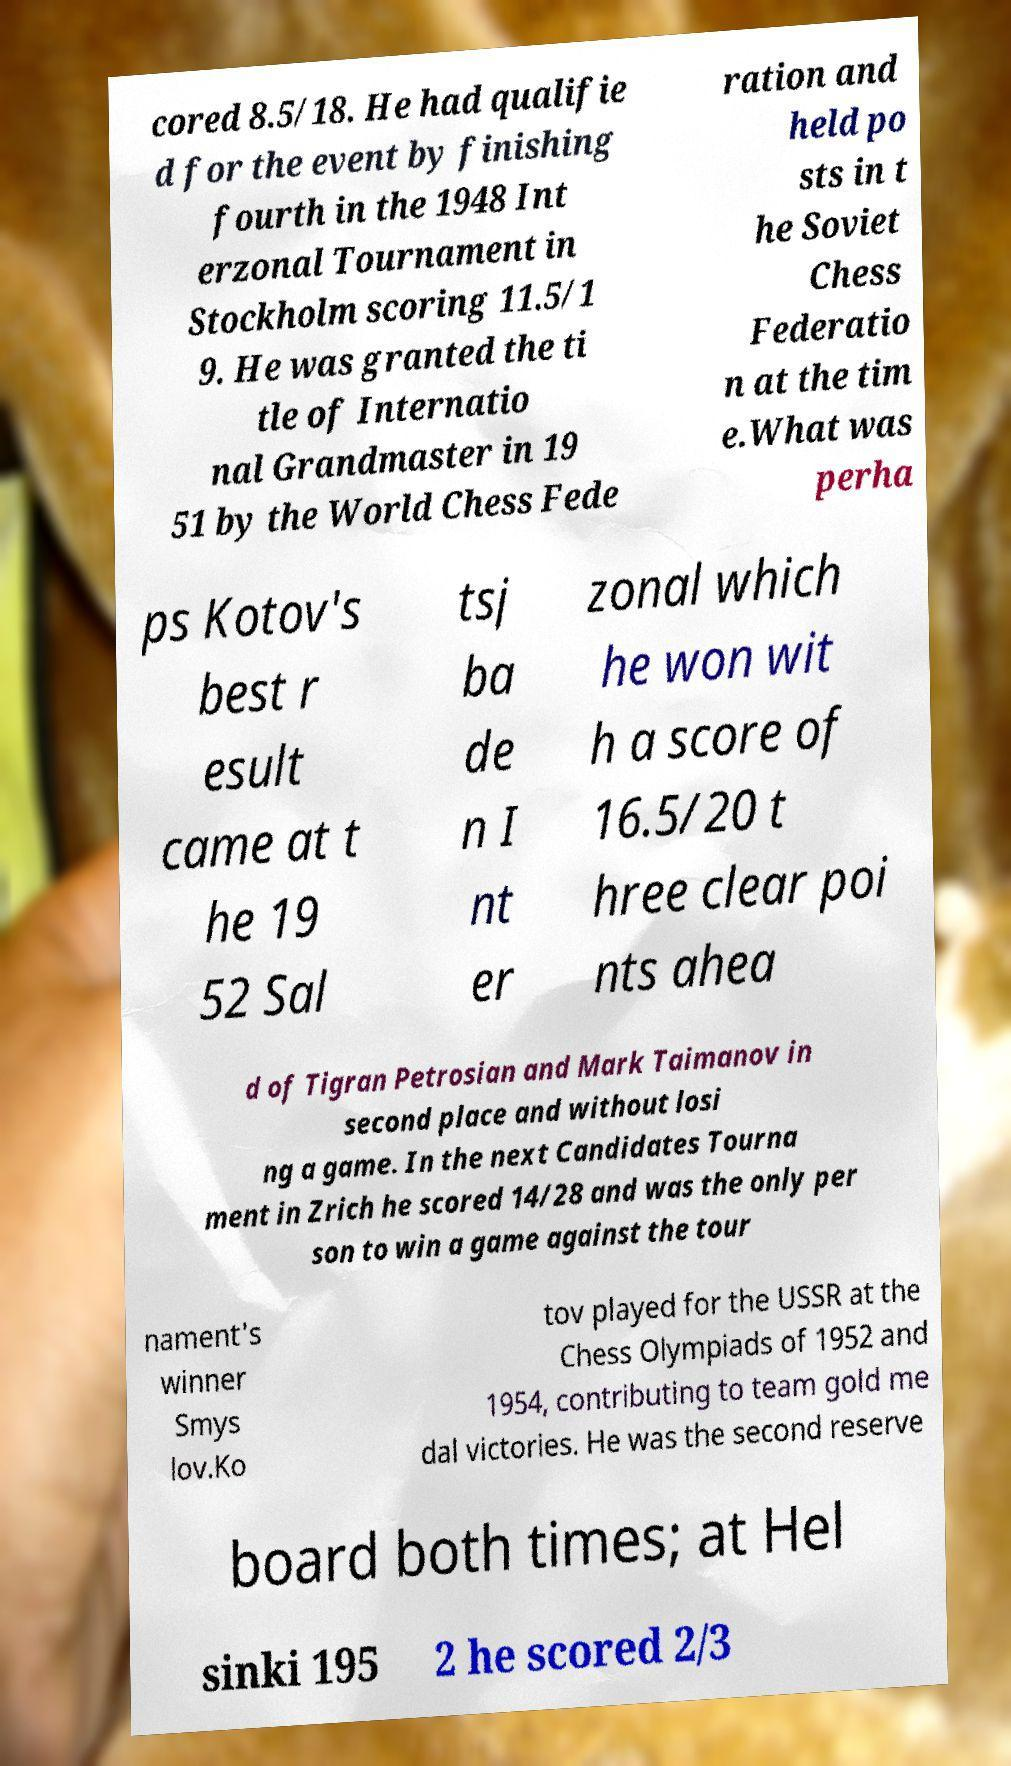Could you extract and type out the text from this image? cored 8.5/18. He had qualifie d for the event by finishing fourth in the 1948 Int erzonal Tournament in Stockholm scoring 11.5/1 9. He was granted the ti tle of Internatio nal Grandmaster in 19 51 by the World Chess Fede ration and held po sts in t he Soviet Chess Federatio n at the tim e.What was perha ps Kotov's best r esult came at t he 19 52 Sal tsj ba de n I nt er zonal which he won wit h a score of 16.5/20 t hree clear poi nts ahea d of Tigran Petrosian and Mark Taimanov in second place and without losi ng a game. In the next Candidates Tourna ment in Zrich he scored 14/28 and was the only per son to win a game against the tour nament's winner Smys lov.Ko tov played for the USSR at the Chess Olympiads of 1952 and 1954, contributing to team gold me dal victories. He was the second reserve board both times; at Hel sinki 195 2 he scored 2/3 